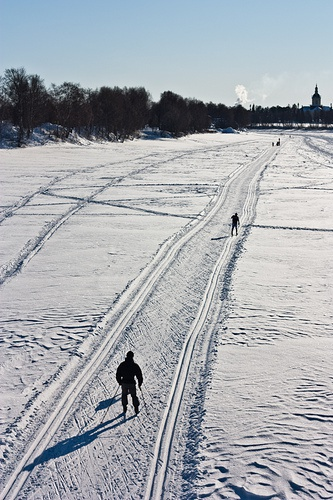Describe the objects in this image and their specific colors. I can see people in lightblue, black, darkgray, gray, and lightgray tones, people in lightblue, black, gray, navy, and darkgray tones, skis in lightblue, black, blue, gray, and navy tones, people in lightblue, black, gray, and darkgray tones, and people in lightblue, gray, darkgray, and black tones in this image. 